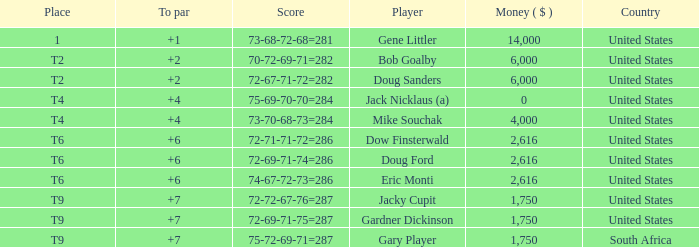What is the highest To Par, when Place is "1"? 1.0. 